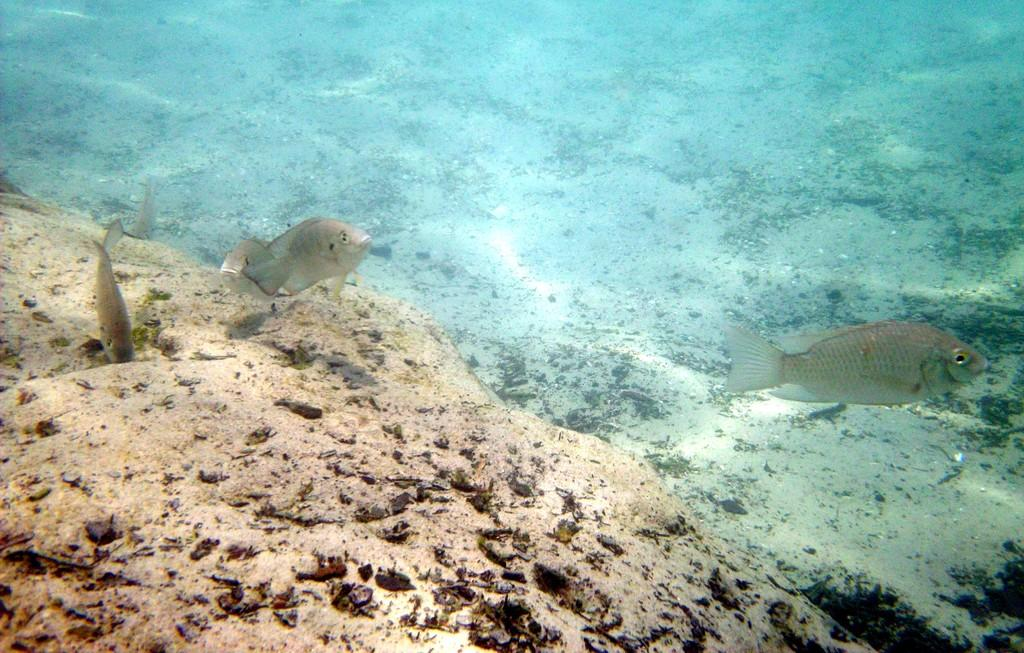What type of animals can be seen in the water in the image? There are fishes in the water in the image. What type of terrain is visible in the image? There is sand visible in the image. What type of net is being used to catch the fishes in the image? There is no net present in the image; the fishes are swimming freely in the water. 